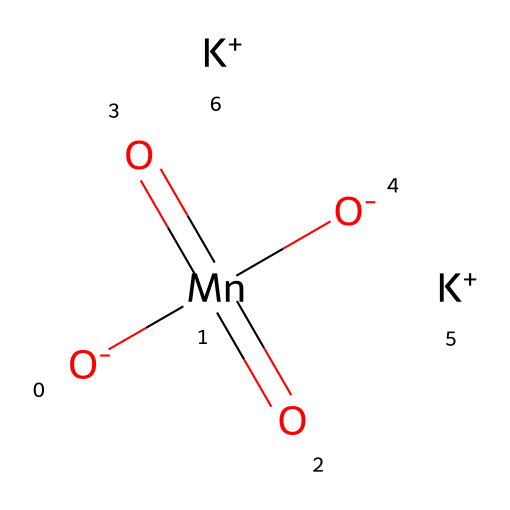What is the overall charge of potassium permanganate in solution? The chemical consists of two potassium ions with a positive charge and one permanganate ion with a net negative charge of -2. Thus, the total charge is neutral overall.
Answer: neutral How many oxygen atoms are present in potassium permanganate? In the structure, there are four oxygen atoms bonded to manganese, indicated by the four [O] symbols in the SMILES representation.
Answer: four What is the oxidation state of manganese in potassium permanganate? The manganese atom (Mn) has an oxidation state of +7, as it is in the +7 state in the permanganate ion. This can be inferred from the bonding and charges in the chemical structure.
Answer: +7 What type of chemical is potassium permanganate primarily classified as? Potassium permanganate is primarily classified as an oxidizer due to its ability to donate oxygen during chemical reactions and enhance the oxidation state of other substances.
Answer: oxidizer How many potassium ions are contained in one formula unit of potassium permanganate? The SMILES representation shows two [K+] symbols, indicating that each formula unit of potassium permanganate contains two potassium ions.
Answer: two What is the color associated with potassium permanganate in water treatment processes? Potassium permanganate typically imparts a purple color when dissolved in water, which can be attributed to its molecular structure and the presence of manganese.
Answer: purple 